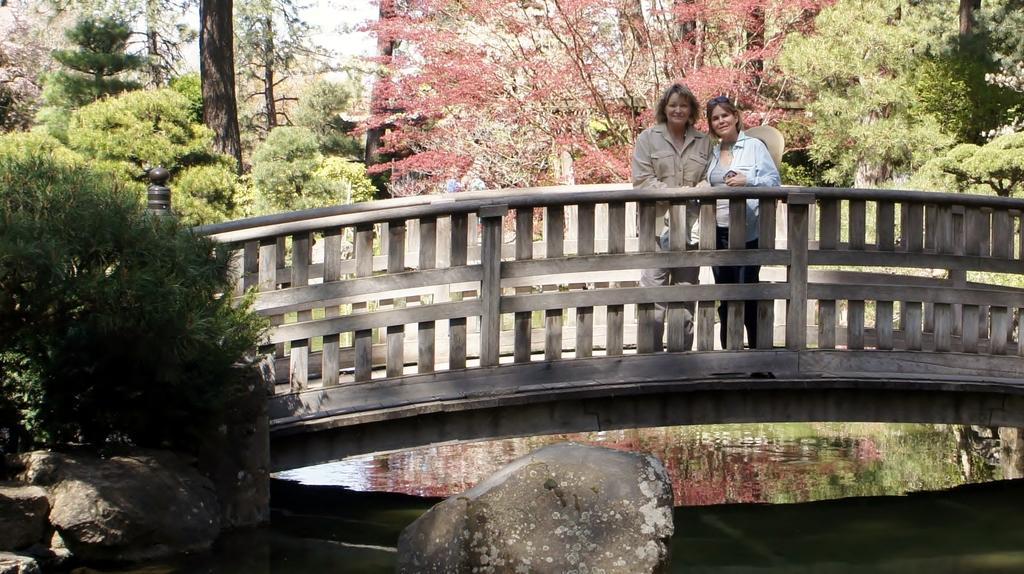Please provide a concise description of this image. In this image we can see a bridge, persons and other objects. In the background of the image there are trees, plants and the sky. At the bottom of the image there are rocks and water. On the water we can see some reflections. 